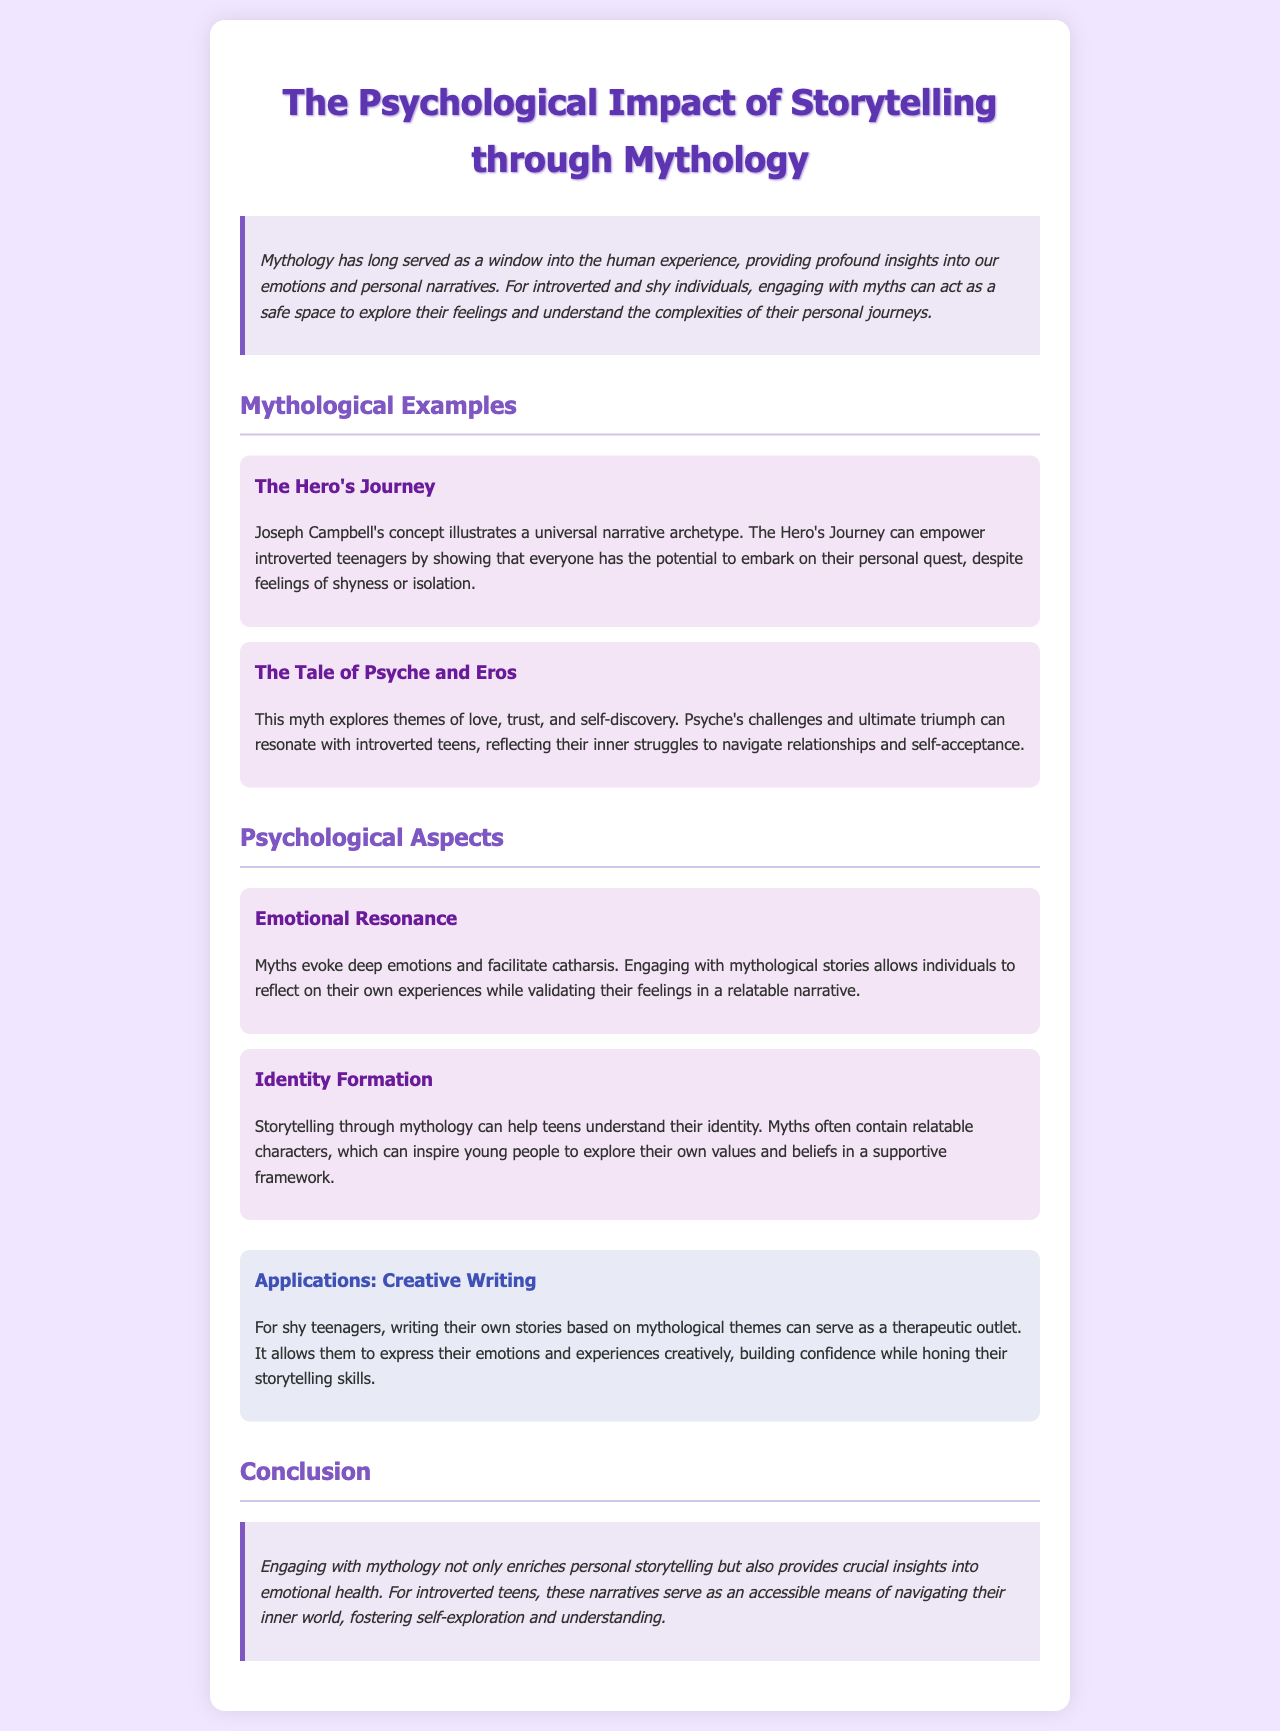What is the title of the document? The title is presented at the top of the document as the main heading.
Answer: The Psychological Impact of Storytelling through Mythology Who is credited with the concept of the Hero's Journey? The document mentions Joseph Campbell in connection with this concept.
Answer: Joseph Campbell What myth is discussed in relation to themes of love and self-discovery? This myth is specifically referenced in the 'Mythological Examples' section.
Answer: The Tale of Psyche and Eros What psychological aspect relates to understanding identity? The document identifies this specific psychological aspect under 'Psychological Aspects'.
Answer: Identity Formation What is a creative application mentioned for shy teenagers? The document advocates for specific creative methods under 'Applications'.
Answer: Creative Writing What is emphasized as a benefit of engaging with mythology? The conclusion highlights this aspect as an important outcome of engaging with myths.
Answer: Emotional health Which hero's journey archetype aims to empower introverted teens? This particular archetype is referred to in the section about 'Mythological Examples'.
Answer: The Hero's Journey What emotive response do myths evoke according to the document? This is discussed under 'Psychological Aspects' and refers to a specific emotional experience.
Answer: Catharsis 